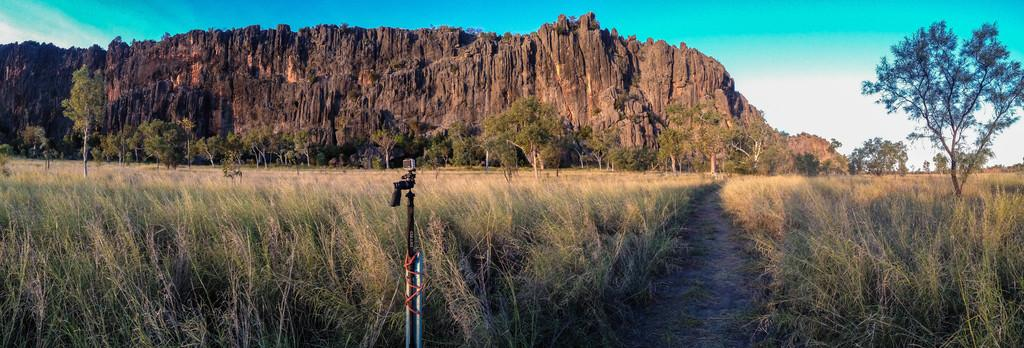What is the main object in the image? There is a camera on a stand in the image. What type of natural environment can be seen in the image? Trees, grass, hills, and the sky are visible in the image. What type of curve can be seen in the image? There is no curve present in the image. What event is taking place in the image? There is no specific event taking place in the image; it simply shows a camera on a stand in a natural environment. 